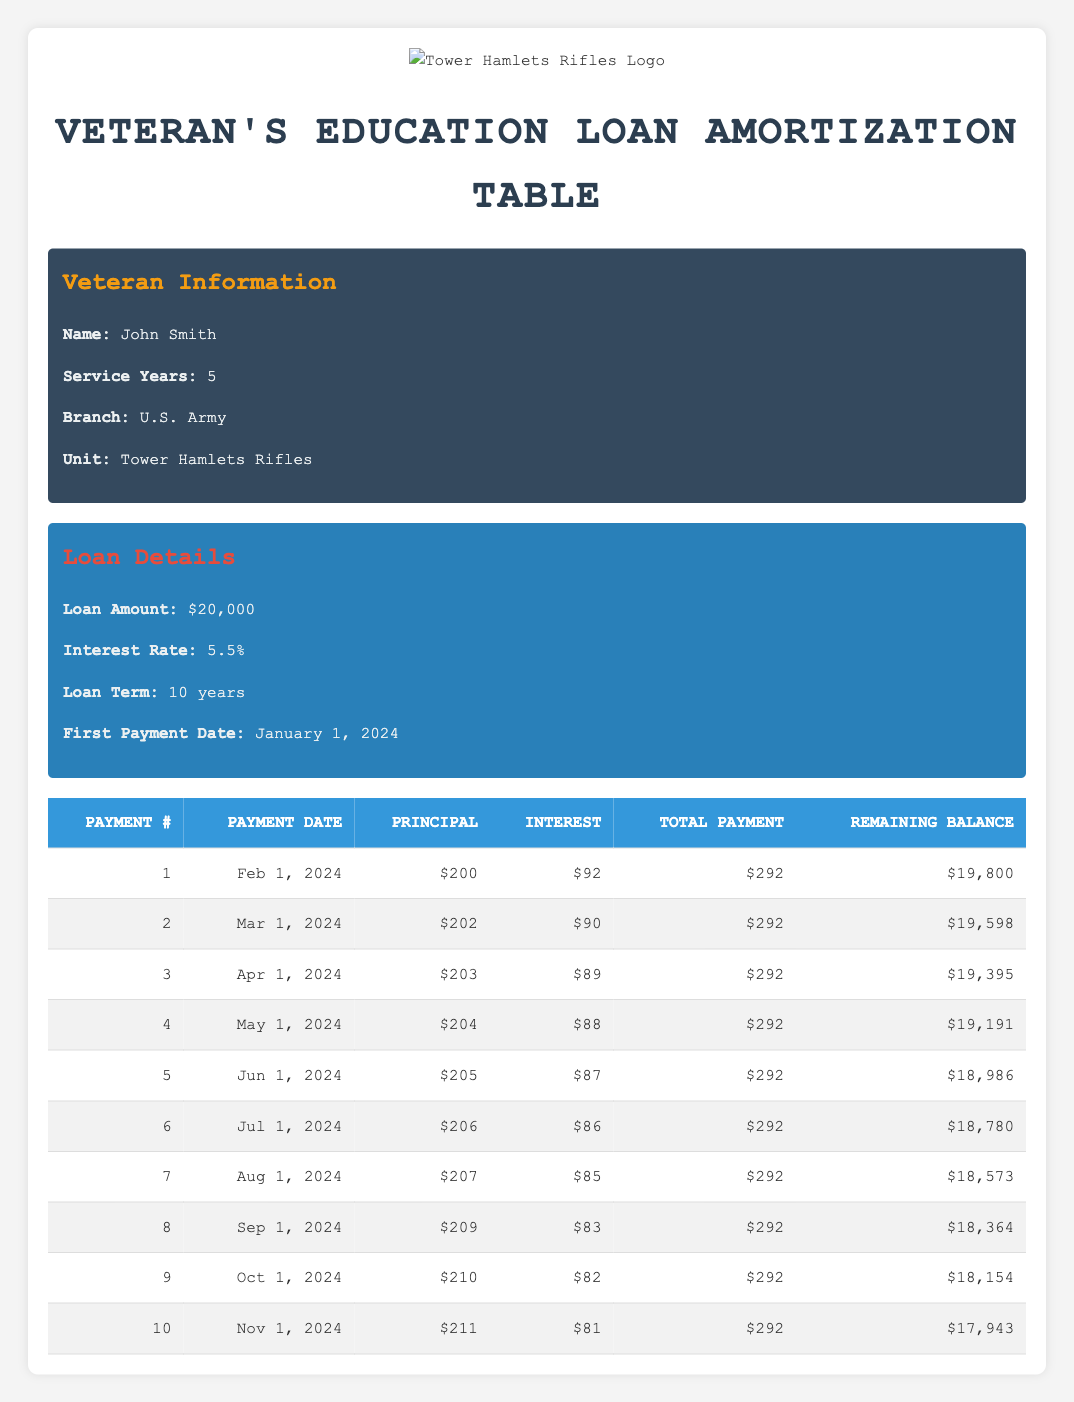What is the total payment amount for the first payment? The total payment amount for the first payment listed in the table is $292, which can be found in the "Total Payment" column of the first row.
Answer: 292 How much is the interest payment for the second payment? The interest payment for the second payment can be found in the second row under the "Interest" column, which shows $90.
Answer: 90 What will be the remaining balance after the fifth payment? The remaining balance after the fifth payment is displayed in the table in the fifth row under the "Remaining Balance" column, which indicates $18,986.
Answer: 18986 What is the average principal payment over the first ten payments? To calculate the average principal payment, add up all the principal payments from the first ten payments (200 + 202 + 203 + 204 + 205 + 206 + 207 + 209 + 210 + 211 = 2081) and divide by the number of payments (10). Therefore, 2081 / 10 = 208.1.
Answer: 208.1 Is the interest payment for the first payment higher than for the second payment? By comparing the interest payments shown in the first two rows, the first payment's interest payment is $92 and the second payment's interest payment is $90. Since $92 is greater than $90, the statement is true.
Answer: Yes What is the total amount paid in interest for the first four payments? To find the total interest paid for the first four payments, add the interest payments from the first to the fourth payment ($92 + $90 + $89 + $88 = $359). Thus, the total interest paid in the first four payments is $359.
Answer: 359 After six payments, how much has John paid towards the loan principal? The principal payments from the first six payments are $200, $202, $203, $204, $205, and $206. Adding these amounts together gives 200 + 202 + 203 + 204 + 205 + 206 = 1,220. Therefore, John has paid a total of $1,220 towards the loan principal after six payments.
Answer: 1220 What is the amount of the principal payment for the eighth payment? The eighth payment's principal amount can be found in the table under the "Principal" column in the eighth row, which indicates $209.
Answer: 209 Is the total payment the same for every month in the first ten payments? All rows from the first to the tenth payment in the "Total Payment" column show the same amount of $292, confirming that it is indeed consistent throughout the payments.
Answer: Yes 